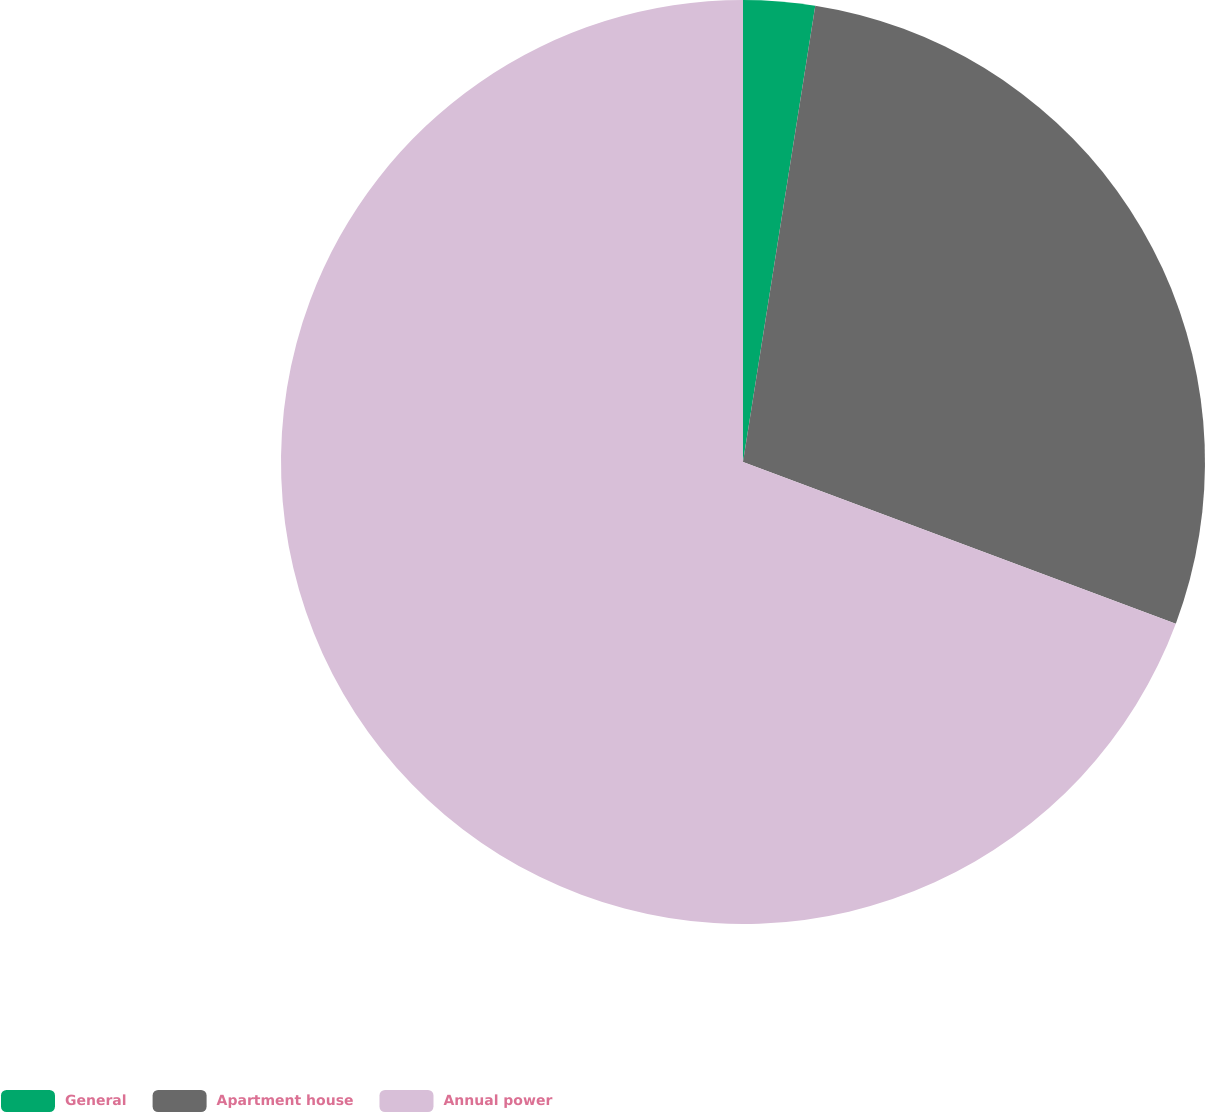Convert chart to OTSL. <chart><loc_0><loc_0><loc_500><loc_500><pie_chart><fcel>General<fcel>Apartment house<fcel>Annual power<nl><fcel>2.5%<fcel>28.19%<fcel>69.31%<nl></chart> 